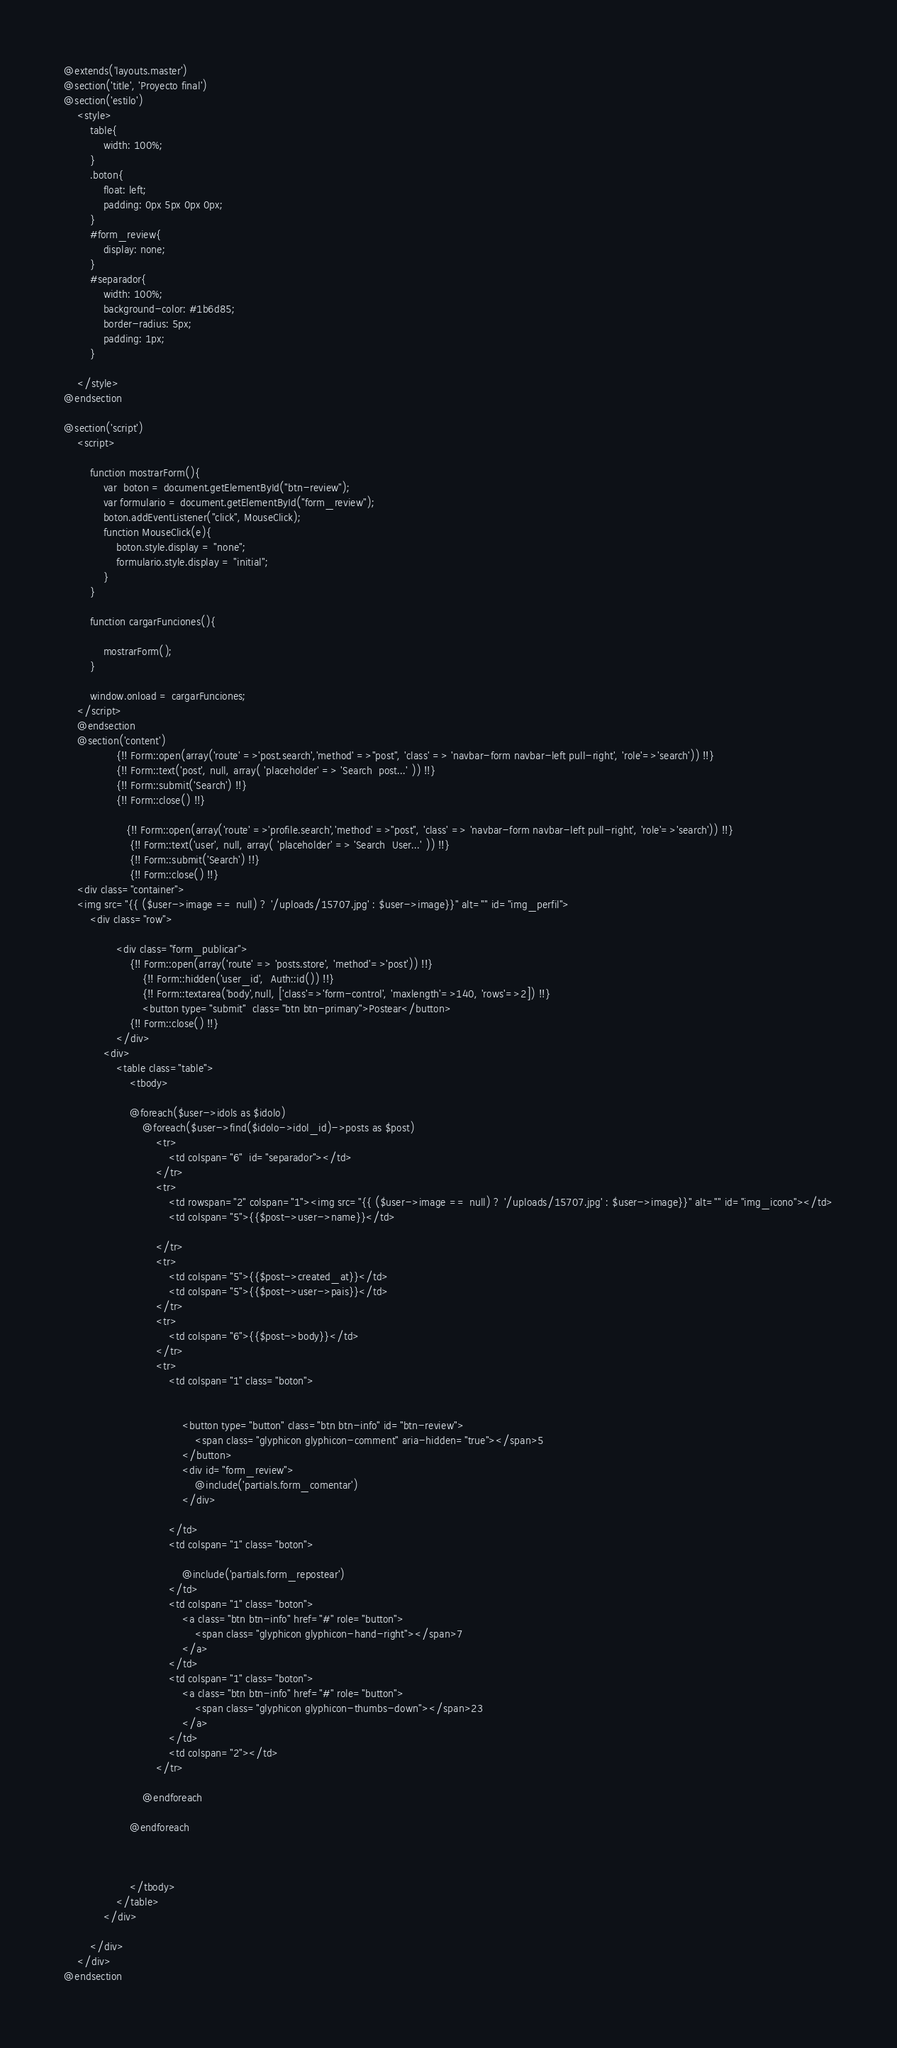Convert code to text. <code><loc_0><loc_0><loc_500><loc_500><_PHP_>@extends('layouts.master')
@section('title', 'Proyecto final')
@section('estilo')
    <style>
        table{
            width: 100%;
        }
        .boton{
            float: left;
            padding: 0px 5px 0px 0px;
        }
        #form_review{
            display: none;
        }
        #separador{
            width: 100%;
            background-color: #1b6d85;
            border-radius: 5px;
            padding: 1px;
        }

    </style>
@endsection

@section('script')
    <script>

        function mostrarForm(){
            var  boton = document.getElementById("btn-review");
            var formulario = document.getElementById("form_review");
            boton.addEventListener("click", MouseClick);
            function MouseClick(e){
                boton.style.display = "none";
                formulario.style.display = "initial";
            }
        }

        function cargarFunciones(){

            mostrarForm();
        }

        window.onload = cargarFunciones;
    </script>
    @endsection
    @section('content')
                {!! Form::open(array('route' =>'post.search','method' =>"post", 'class' => 'navbar-form navbar-left pull-right', 'role'=>'search')) !!}
                {!! Form::text('post', null, array( 'placeholder' => 'Search  post...' )) !!}
                {!! Form::submit('Search') !!}
                {!! Form::close() !!}

                   {!! Form::open(array('route' =>'profile.search','method' =>"post", 'class' => 'navbar-form navbar-left pull-right', 'role'=>'search')) !!}
                    {!! Form::text('user', null, array( 'placeholder' => 'Search  User...' )) !!}
                    {!! Form::submit('Search') !!}
                    {!! Form::close() !!}
    <div class="container">
    <img src="{{ ($user->image == null) ? '/uploads/15707.jpg' : $user->image}}" alt="" id="img_perfil">
        <div class="row">

                <div class="form_publicar">
                    {!! Form::open(array('route' => 'posts.store', 'method'=>'post')) !!}
                        {!! Form::hidden('user_id',  Auth::id()) !!}
                        {!! Form::textarea('body',null, ['class'=>'form-control', 'maxlength'=>140, 'rows'=>2]) !!}
                        <button type="submit"  class="btn btn-primary">Postear</button>
                    {!! Form::close() !!}
                </div>
            <div>
                <table class="table">
                    <tbody>

                    @foreach($user->idols as $idolo)
                        @foreach($user->find($idolo->idol_id)->posts as $post)
                            <tr>
                                <td colspan="6"  id="separador"></td>
                            </tr>
                            <tr>
                                <td rowspan="2" colspan="1"><img src="{{ ($user->image == null) ? '/uploads/15707.jpg' : $user->image}}" alt="" id="img_icono"></td>
                                <td colspan="5">{{$post->user->name}}</td>

                            </tr>
                            <tr>
                                <td colspan="5">{{$post->created_at}}</td>
                                <td colspan="5">{{$post->user->pais}}</td>
                            </tr>
                            <tr>
                                <td colspan="6">{{$post->body}}</td>
                            </tr>
                            <tr>
                                <td colspan="1" class="boton">


                                    <button type="button" class="btn btn-info" id="btn-review">
                                        <span class="glyphicon glyphicon-comment" aria-hidden="true"></span>5
                                    </button>
                                    <div id="form_review">
                                        @include('partials.form_comentar')
                                    </div>

                                </td>
                                <td colspan="1" class="boton">

                                    @include('partials.form_repostear')
                                </td>
                                <td colspan="1" class="boton">
                                    <a class="btn btn-info" href="#" role="button">
                                        <span class="glyphicon glyphicon-hand-right"></span>7
                                    </a>
                                </td>
                                <td colspan="1" class="boton">
                                    <a class="btn btn-info" href="#" role="button">
                                        <span class="glyphicon glyphicon-thumbs-down"></span>23
                                    </a>
                                </td>
                                <td colspan="2"></td>
                            </tr>

                        @endforeach

                    @endforeach



                    </tbody>
                </table>
            </div>

        </div>
    </div>
@endsection


</code> 